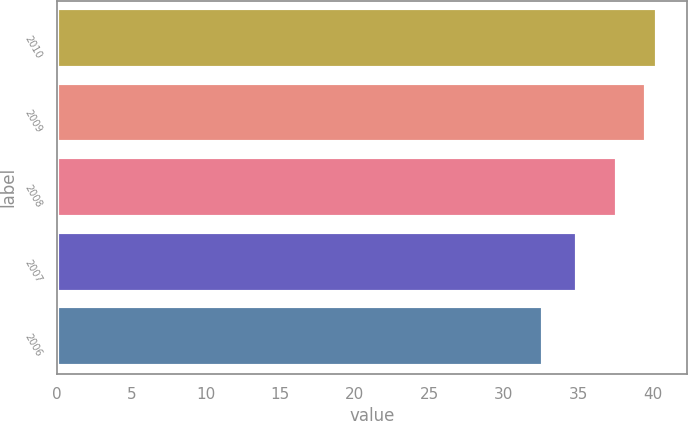<chart> <loc_0><loc_0><loc_500><loc_500><bar_chart><fcel>2010<fcel>2009<fcel>2008<fcel>2007<fcel>2006<nl><fcel>40.27<fcel>39.56<fcel>37.59<fcel>34.94<fcel>32.64<nl></chart> 